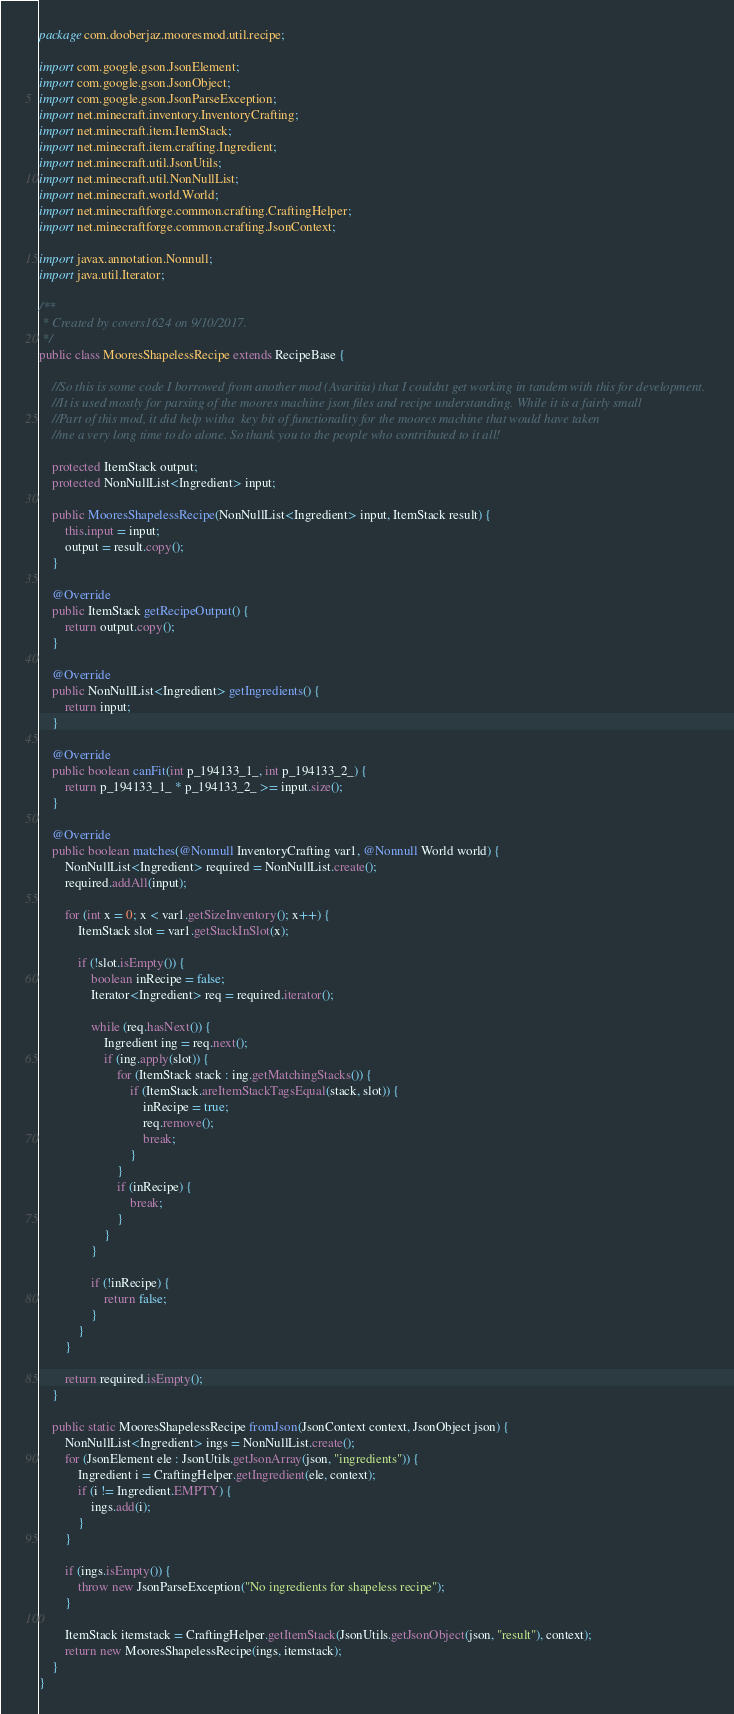Convert code to text. <code><loc_0><loc_0><loc_500><loc_500><_Java_>package com.dooberjaz.mooresmod.util.recipe;

import com.google.gson.JsonElement;
import com.google.gson.JsonObject;
import com.google.gson.JsonParseException;
import net.minecraft.inventory.InventoryCrafting;
import net.minecraft.item.ItemStack;
import net.minecraft.item.crafting.Ingredient;
import net.minecraft.util.JsonUtils;
import net.minecraft.util.NonNullList;
import net.minecraft.world.World;
import net.minecraftforge.common.crafting.CraftingHelper;
import net.minecraftforge.common.crafting.JsonContext;

import javax.annotation.Nonnull;
import java.util.Iterator;

/**
 * Created by covers1624 on 9/10/2017.
 */
public class MooresShapelessRecipe extends RecipeBase {

    //So this is some code I borrowed from another mod (Avaritia) that I couldnt get working in tandem with this for development.
    //It is used mostly for parsing of the moores machine json files and recipe understanding. While it is a fairly small
    //Part of this mod, it did help witha  key bit of functionality for the moores machine that would have taken
    //me a very long time to do alone. So thank you to the people who contributed to it all!

    protected ItemStack output;
    protected NonNullList<Ingredient> input;

    public MooresShapelessRecipe(NonNullList<Ingredient> input, ItemStack result) {
        this.input = input;
        output = result.copy();
    }

    @Override
    public ItemStack getRecipeOutput() {
        return output.copy();
    }

    @Override
    public NonNullList<Ingredient> getIngredients() {
        return input;
    }

    @Override
    public boolean canFit(int p_194133_1_, int p_194133_2_) {
        return p_194133_1_ * p_194133_2_ >= input.size();
    }

    @Override
    public boolean matches(@Nonnull InventoryCrafting var1, @Nonnull World world) {
        NonNullList<Ingredient> required = NonNullList.create();
        required.addAll(input);

        for (int x = 0; x < var1.getSizeInventory(); x++) {
            ItemStack slot = var1.getStackInSlot(x);

            if (!slot.isEmpty()) {
                boolean inRecipe = false;
                Iterator<Ingredient> req = required.iterator();

                while (req.hasNext()) {
                    Ingredient ing = req.next();
                    if (ing.apply(slot)) {
                        for (ItemStack stack : ing.getMatchingStacks()) {
                            if (ItemStack.areItemStackTagsEqual(stack, slot)) {
                                inRecipe = true;
                                req.remove();
                                break;
                            }
                        }
                        if (inRecipe) {
                            break;
                        }
                    }
                }

                if (!inRecipe) {
                    return false;
                }
            }
        }

        return required.isEmpty();
    }

    public static MooresShapelessRecipe fromJson(JsonContext context, JsonObject json) {
        NonNullList<Ingredient> ings = NonNullList.create();
        for (JsonElement ele : JsonUtils.getJsonArray(json, "ingredients")) {
            Ingredient i = CraftingHelper.getIngredient(ele, context);
            if (i != Ingredient.EMPTY) {
                ings.add(i);
            }
        }

        if (ings.isEmpty()) {
            throw new JsonParseException("No ingredients for shapeless recipe");
        }

        ItemStack itemstack = CraftingHelper.getItemStack(JsonUtils.getJsonObject(json, "result"), context);
        return new MooresShapelessRecipe(ings, itemstack);
    }
}
</code> 